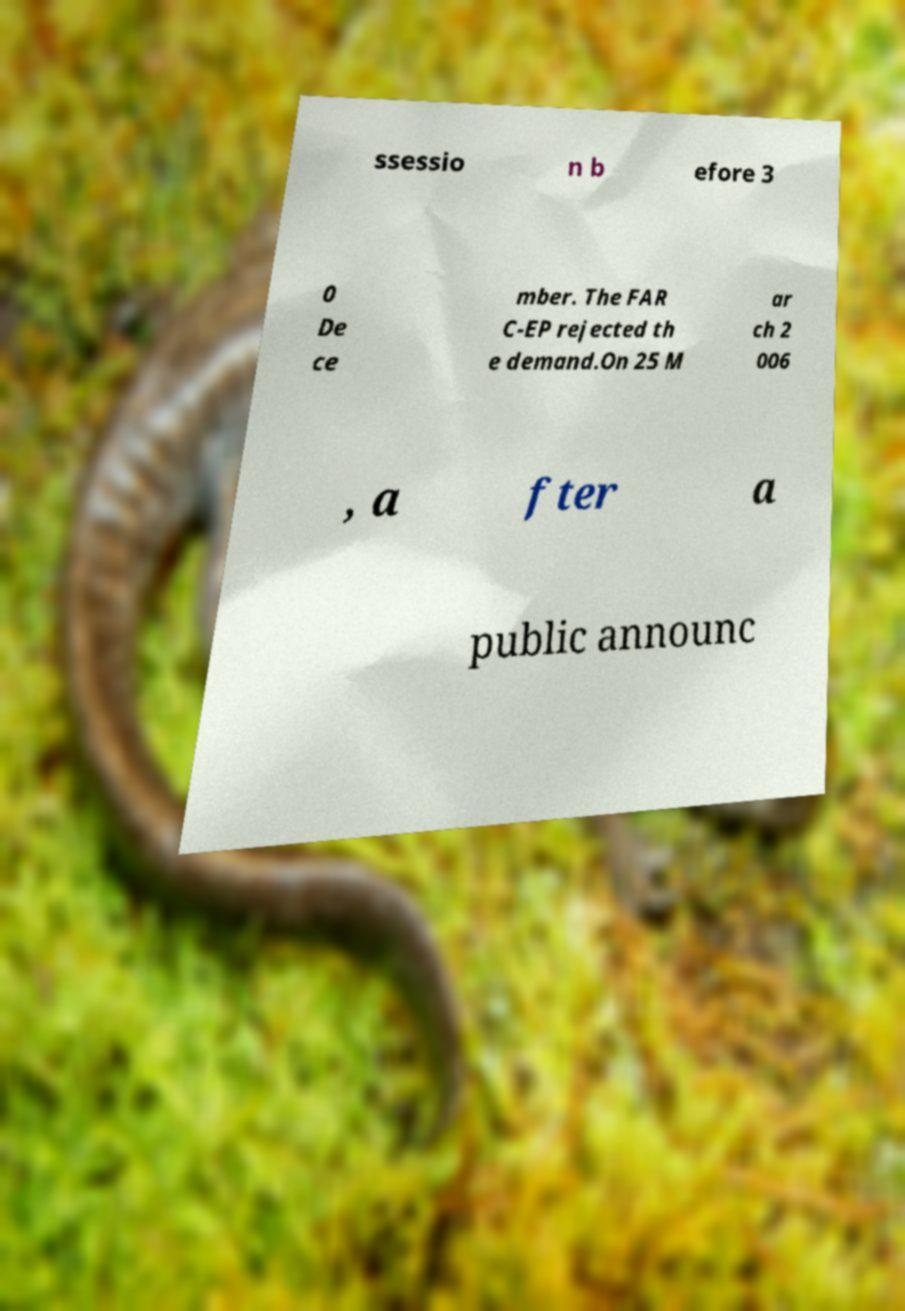Could you assist in decoding the text presented in this image and type it out clearly? ssessio n b efore 3 0 De ce mber. The FAR C-EP rejected th e demand.On 25 M ar ch 2 006 , a fter a public announc 